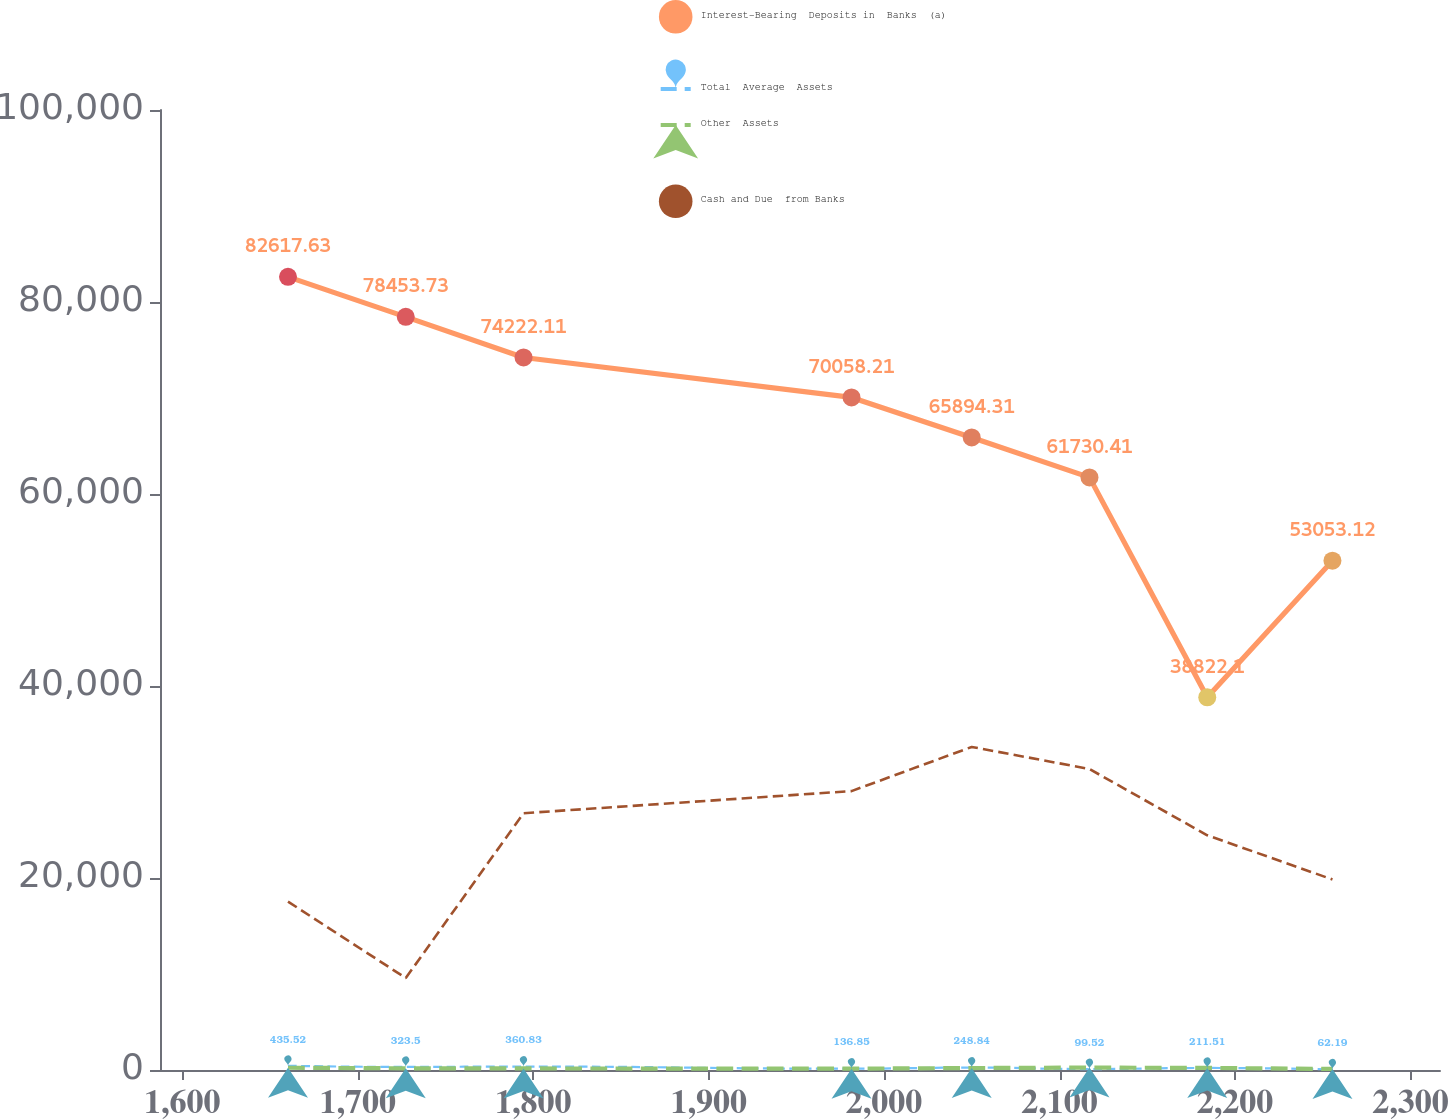<chart> <loc_0><loc_0><loc_500><loc_500><line_chart><ecel><fcel>Interest-Bearing  Deposits in  Banks  (a)<fcel>Total  Average  Assets<fcel>Other  Assets<fcel>Cash and Due  from Banks<nl><fcel>1660.22<fcel>82617.6<fcel>435.52<fcel>233.56<fcel>17544.3<nl><fcel>1727.35<fcel>78453.7<fcel>323.5<fcel>175.37<fcel>9578.6<nl><fcel>1794.48<fcel>74222.1<fcel>360.83<fcel>159.87<fcel>26750.2<nl><fcel>1981.43<fcel>70058.2<fcel>136.85<fcel>140.56<fcel>29051.7<nl><fcel>2049.93<fcel>65894.3<fcel>248.84<fcel>202.56<fcel>33654.7<nl><fcel>2117.06<fcel>61730.4<fcel>99.52<fcel>249.06<fcel>31353.2<nl><fcel>2184.19<fcel>38822.1<fcel>211.51<fcel>218.06<fcel>24448.7<nl><fcel>2255.55<fcel>53053.1<fcel>62.19<fcel>109.56<fcel>19845.8<nl><fcel>2322.68<fcel>48889.2<fcel>174.18<fcel>94.06<fcel>22147.3<nl><fcel>2389.81<fcel>44725.3<fcel>286.17<fcel>125.06<fcel>15242.8<nl></chart> 